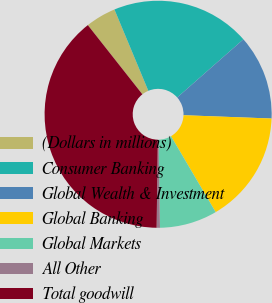Convert chart. <chart><loc_0><loc_0><loc_500><loc_500><pie_chart><fcel>(Dollars in millions)<fcel>Consumer Banking<fcel>Global Wealth & Investment<fcel>Global Banking<fcel>Global Markets<fcel>All Other<fcel>Total goodwill<nl><fcel>4.34%<fcel>19.81%<fcel>12.07%<fcel>15.94%<fcel>8.2%<fcel>0.47%<fcel>39.16%<nl></chart> 